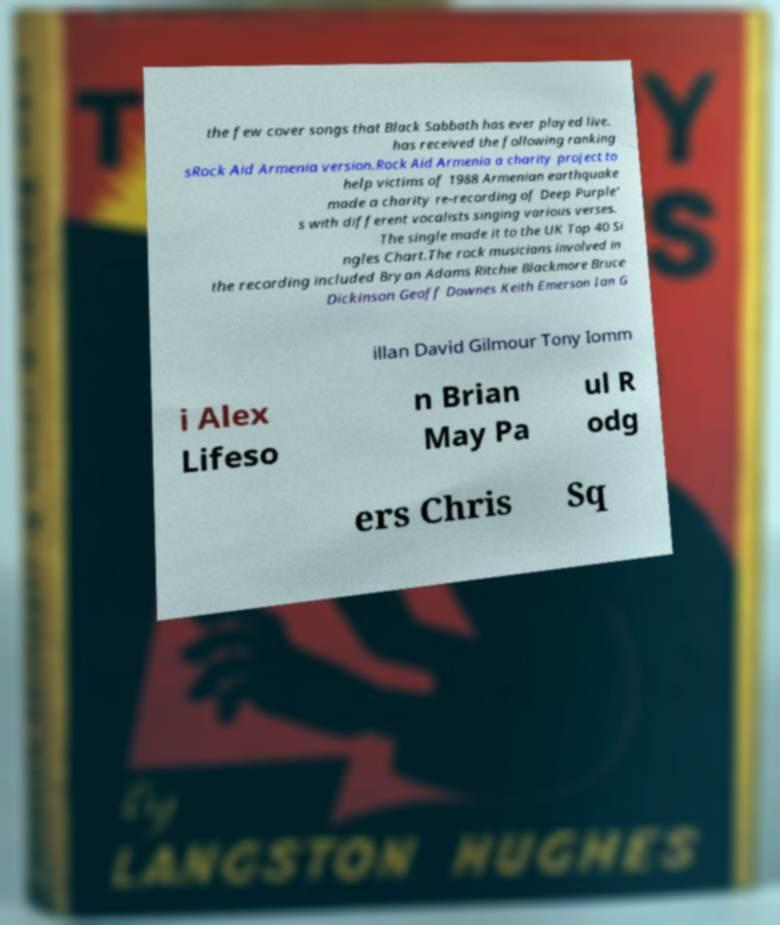For documentation purposes, I need the text within this image transcribed. Could you provide that? the few cover songs that Black Sabbath has ever played live. has received the following ranking sRock Aid Armenia version.Rock Aid Armenia a charity project to help victims of 1988 Armenian earthquake made a charity re-recording of Deep Purple' s with different vocalists singing various verses. The single made it to the UK Top 40 Si ngles Chart.The rock musicians involved in the recording included Bryan Adams Ritchie Blackmore Bruce Dickinson Geoff Downes Keith Emerson Ian G illan David Gilmour Tony Iomm i Alex Lifeso n Brian May Pa ul R odg ers Chris Sq 